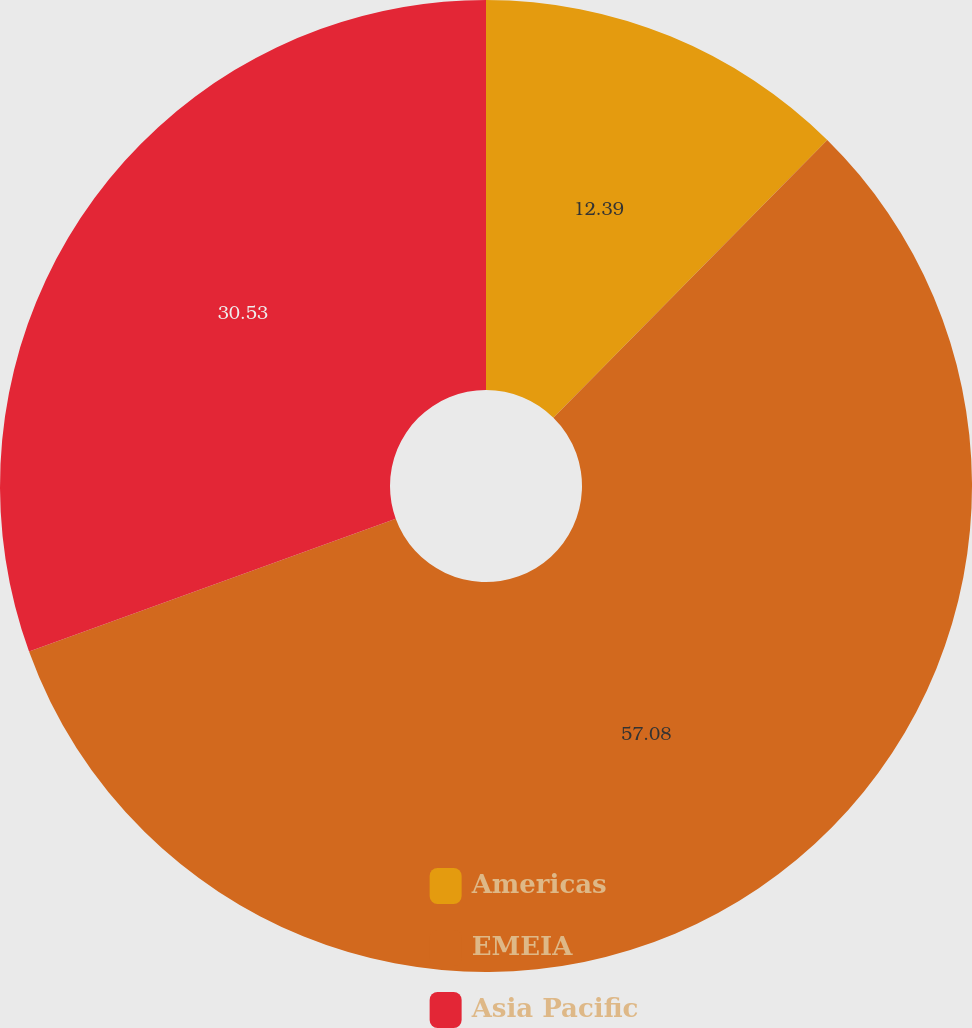<chart> <loc_0><loc_0><loc_500><loc_500><pie_chart><fcel>Americas<fcel>EMEIA<fcel>Asia Pacific<nl><fcel>12.39%<fcel>57.08%<fcel>30.53%<nl></chart> 